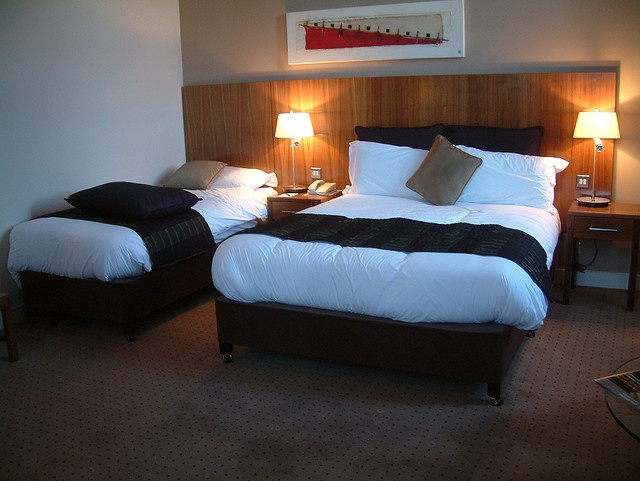Describe the objects in this image and their specific colors. I can see bed in gray, black, and lightblue tones and bed in gray, black, and white tones in this image. 